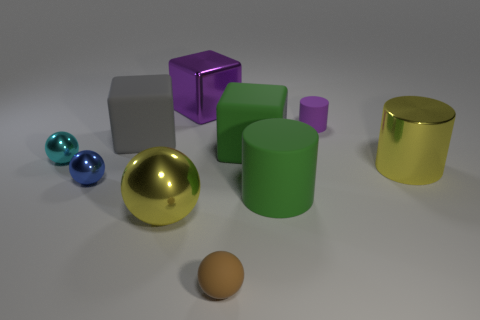Subtract 1 balls. How many balls are left? 3 Subtract all cylinders. How many objects are left? 7 Subtract 0 red cylinders. How many objects are left? 10 Subtract all tiny blue matte cylinders. Subtract all large rubber cylinders. How many objects are left? 9 Add 3 purple cubes. How many purple cubes are left? 4 Add 6 big shiny cubes. How many big shiny cubes exist? 7 